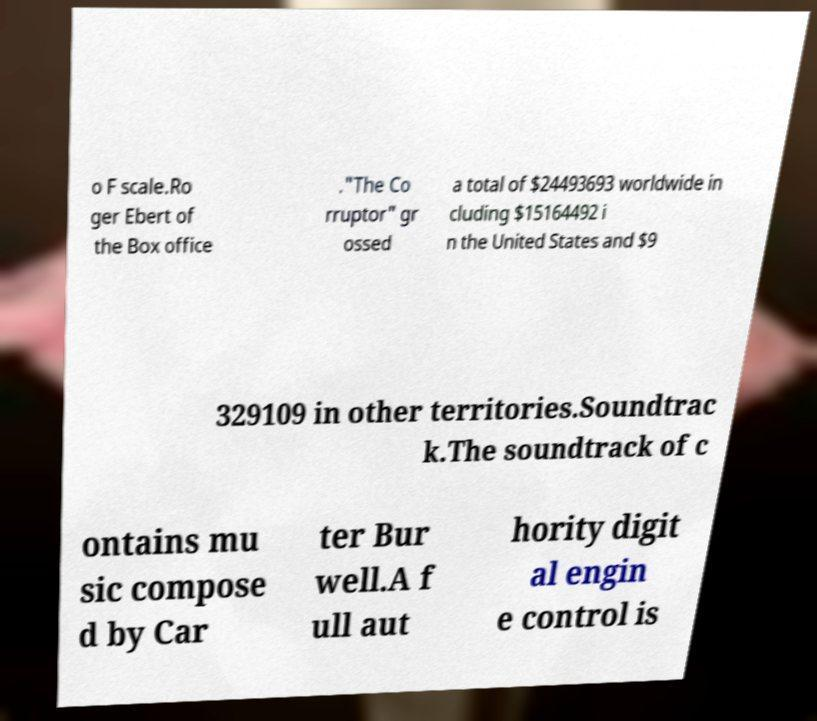There's text embedded in this image that I need extracted. Can you transcribe it verbatim? o F scale.Ro ger Ebert of the Box office ."The Co rruptor" gr ossed a total of $24493693 worldwide in cluding $15164492 i n the United States and $9 329109 in other territories.Soundtrac k.The soundtrack of c ontains mu sic compose d by Car ter Bur well.A f ull aut hority digit al engin e control is 